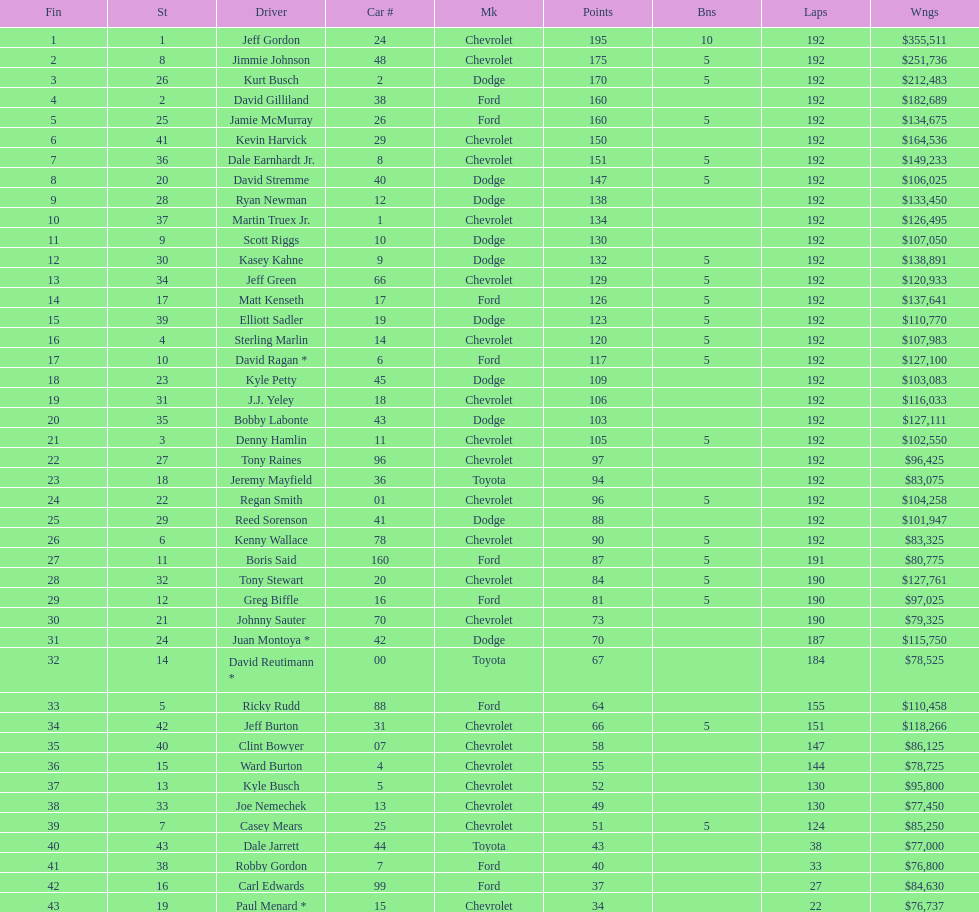Which make had the most consecutive finishes at the aarons 499? Chevrolet. 